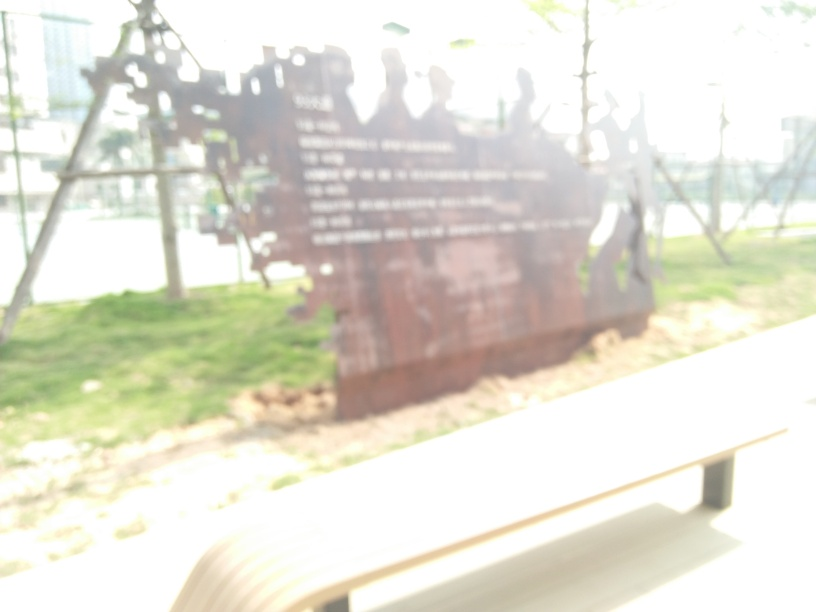Can you describe the setting or environment seen in this image? The image depicts an outdoor scene, likely a park or a public space, given the presence of greenery such as grass. However, due to the blur, it's challenging to provide specific details about the exact location or the objects within. 